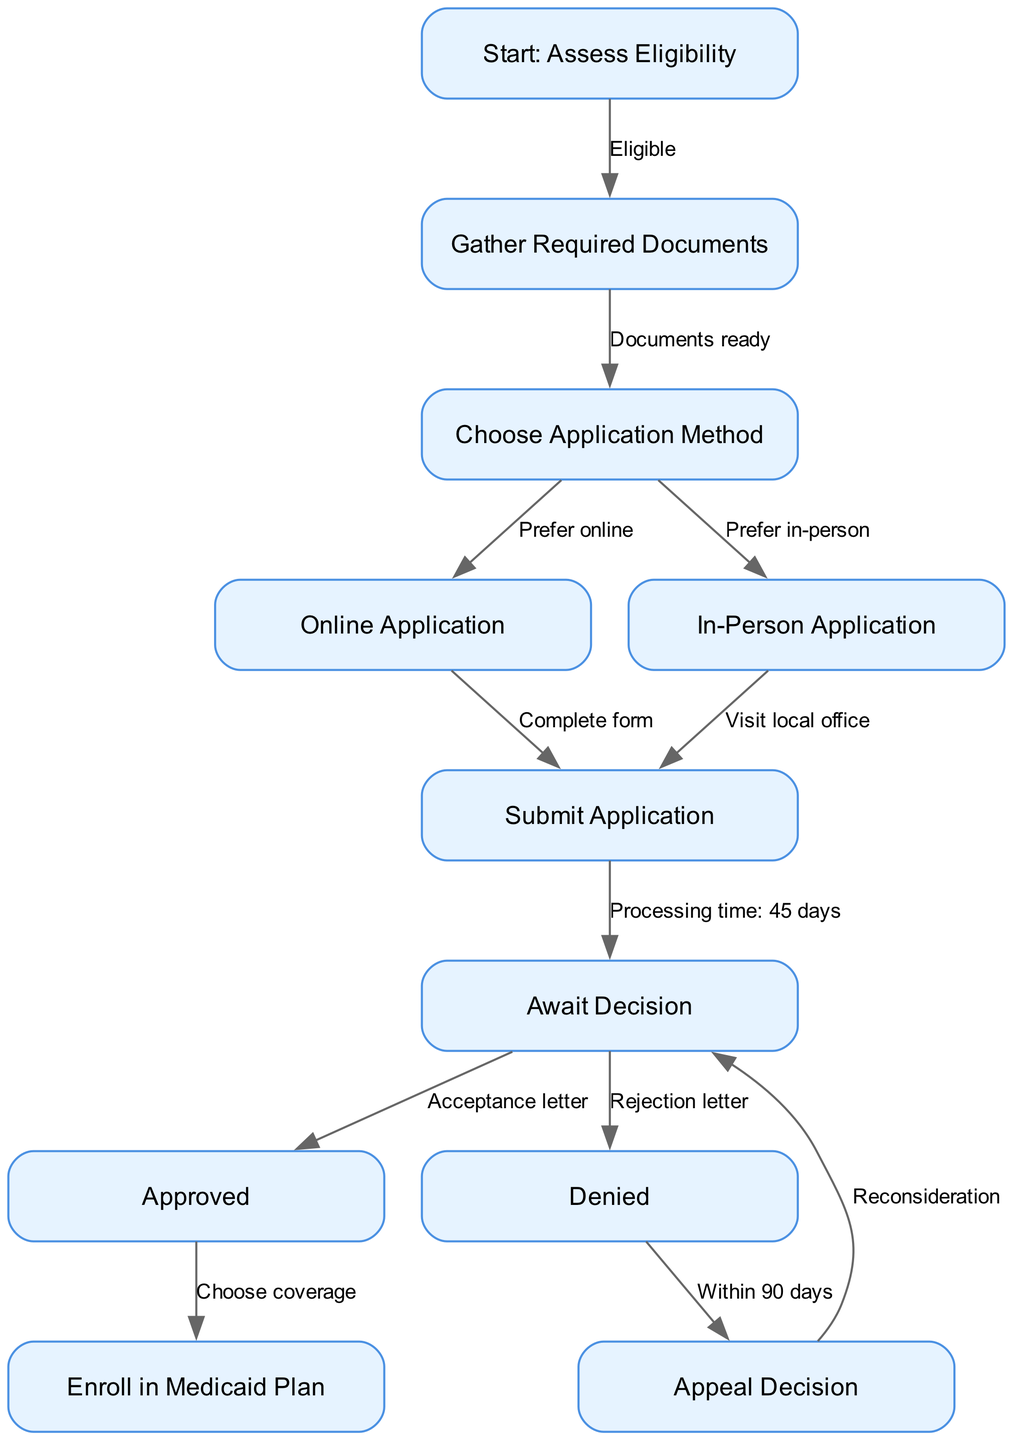What is the first step in the flowchart? The first step in the flowchart is labeled "Start: Assess Eligibility." This node clearly indicates the initial action one must take when applying for government healthcare assistance programs.
Answer: Start: Assess Eligibility How many nodes are in the diagram? By counting each unique labeled step in the flowchart, we find that there are a total of 11 nodes, representing different stages in the application process for Medicaid.
Answer: 11 What does the edge from "Submit Application" to "Await Decision" indicate? The edge from "Submit Application" to "Await Decision" signifies that once you submit your application, you will enter the stage of waiting for a decision regarding your application status, which typically takes time.
Answer: Processing time: 45 days If the application is denied, what is the next step? If the application is denied, the next step is to "Appeal Decision." This indicates that there is a process available for individuals to contest or request reconsideration of the denial.
Answer: Appeal Decision What happens if the application gets approved? Upon approval of the application, the next action is to "Enroll in Medicaid Plan," meaning that individuals can select the specific health coverage options offered under Medicaid.
Answer: Enroll in Medicaid Plan What can you do within 90 days after being denied? Within 90 days after receiving denial, you can choose to "Appeal Decision," indicating that there is a time frame within which you must act if you wish to contest the decision.
Answer: Within 90 days Which node is reached when choosing to apply online? Choosing to apply online leads directly to the node labeled "Online Application." This indicates that if you prefer the online method, you will proceed to complete the required steps specific to that option.
Answer: Online Application How does one proceed after gathering required documents? After gathering required documents, one progresses to "Choose Application Method," which serves as the decision point for whether to apply online or in-person based on personal preference.
Answer: Choose Application Method 